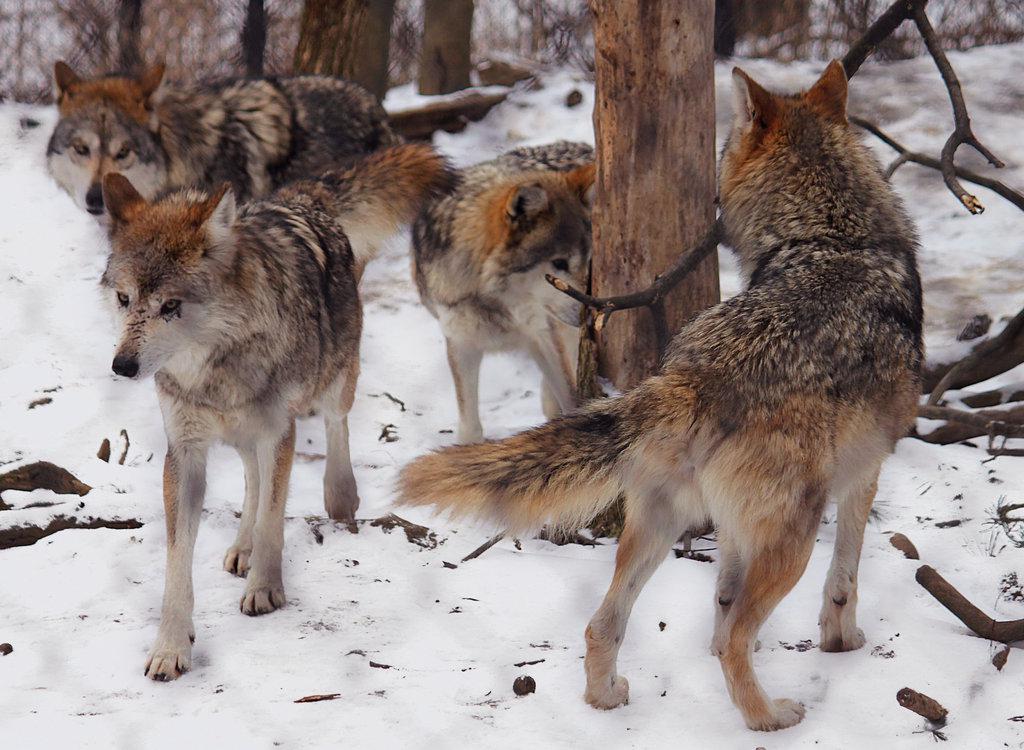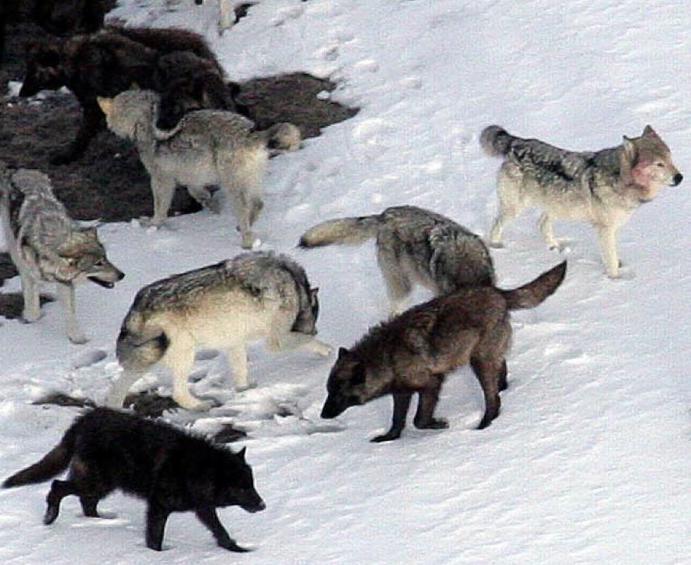The first image is the image on the left, the second image is the image on the right. Evaluate the accuracy of this statement regarding the images: "Three wild dogs are in the snow in the image on the left.". Is it true? Answer yes or no. No. The first image is the image on the left, the second image is the image on the right. Considering the images on both sides, is "An image shows wolves bounding across the snow." valid? Answer yes or no. No. 